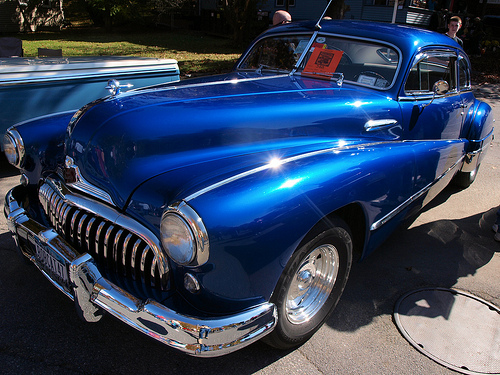<image>
Is there a car behind the man? No. The car is not behind the man. From this viewpoint, the car appears to be positioned elsewhere in the scene. 